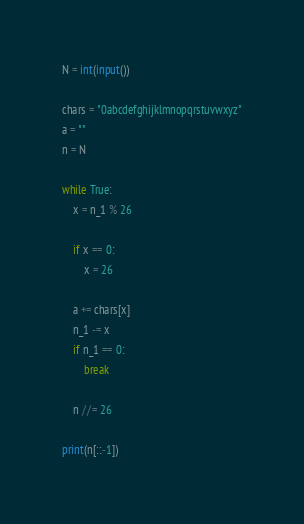<code> <loc_0><loc_0><loc_500><loc_500><_Python_>N = int(input())

chars = "0abcdefghijklmnopqrstuvwxyz"
a = ""
n = N

while True:
    x = n_1 % 26

    if x == 0:
        x = 26

    a += chars[x]
    n_1 -= x
    if n_1 == 0:
        break

    n //= 26

print(n[::-1])</code> 